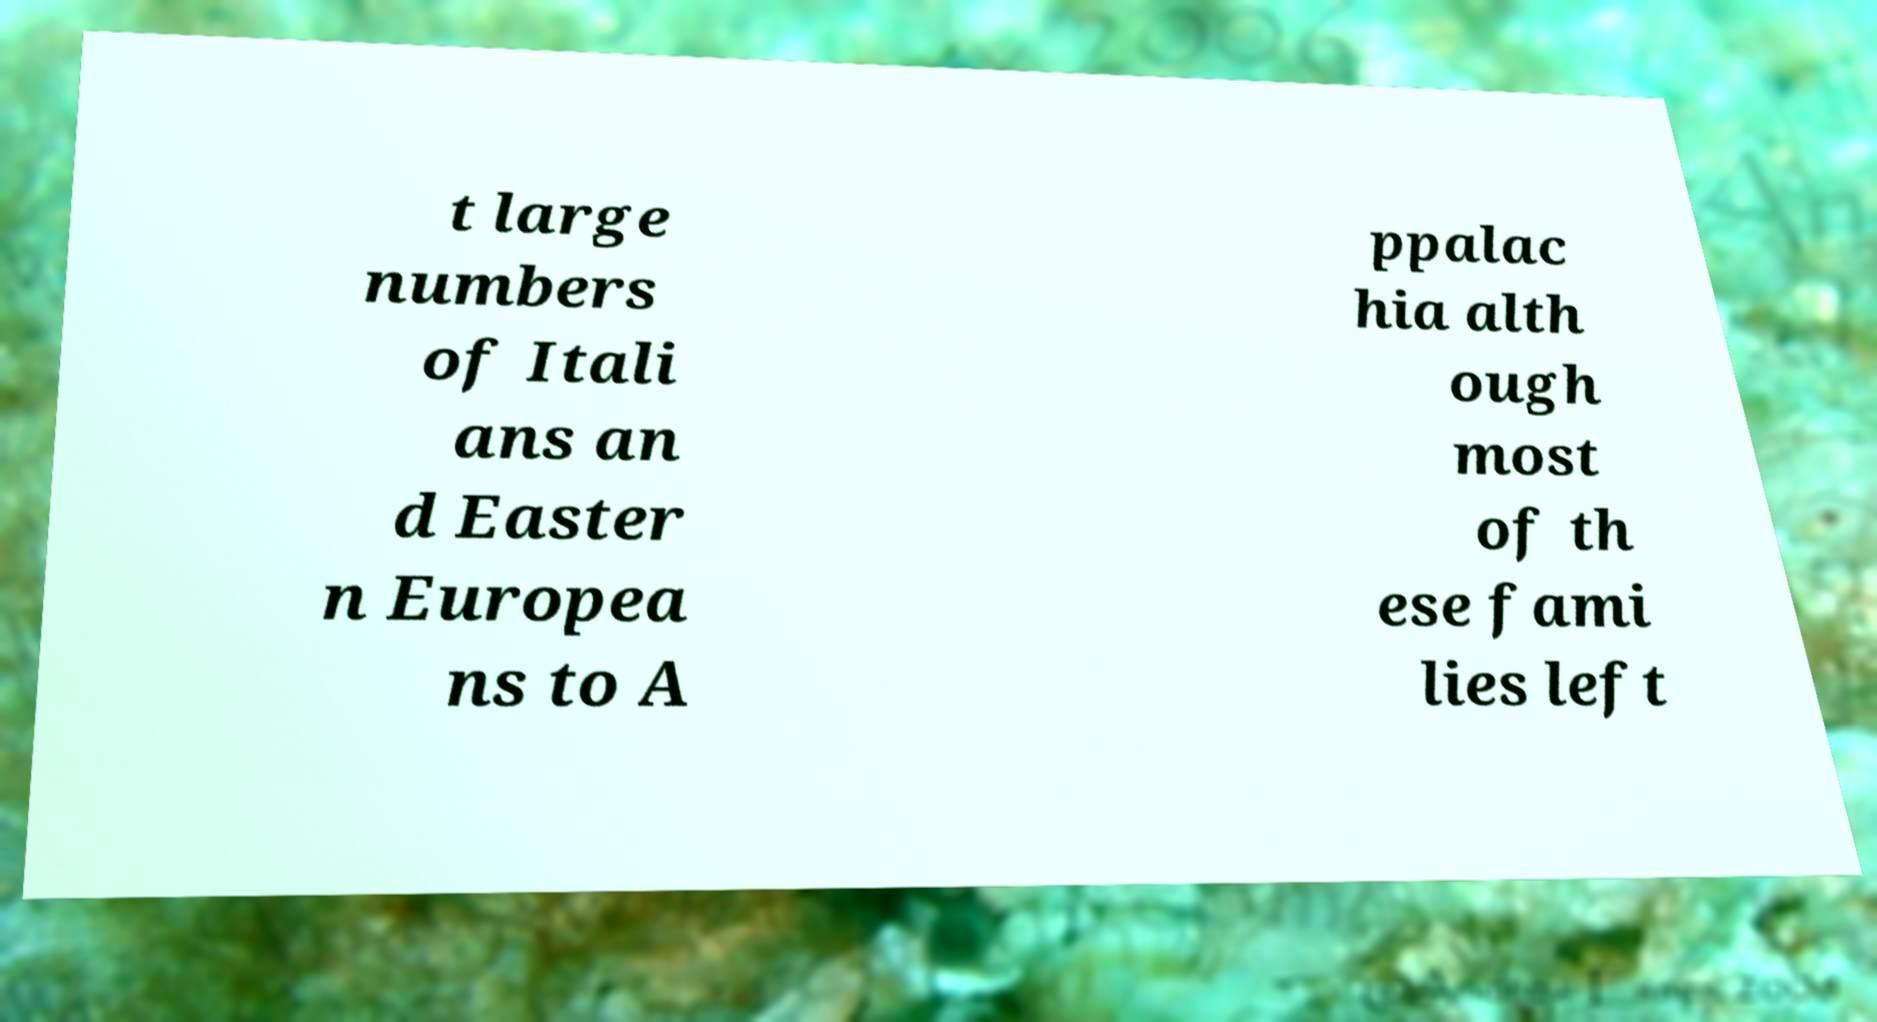Could you assist in decoding the text presented in this image and type it out clearly? t large numbers of Itali ans an d Easter n Europea ns to A ppalac hia alth ough most of th ese fami lies left 